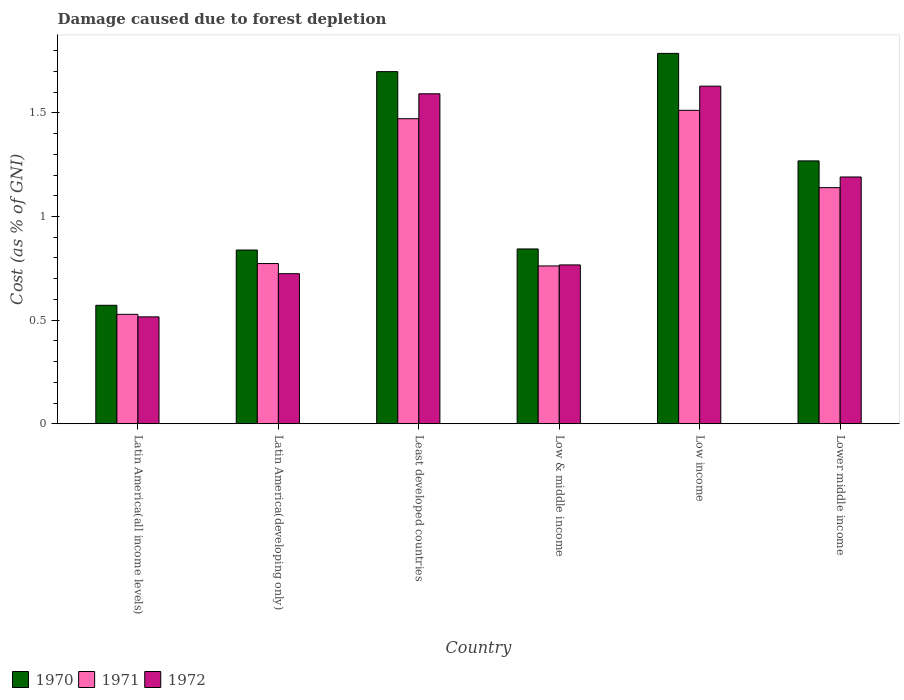How many groups of bars are there?
Provide a short and direct response. 6. Are the number of bars per tick equal to the number of legend labels?
Offer a very short reply. Yes. Are the number of bars on each tick of the X-axis equal?
Give a very brief answer. Yes. How many bars are there on the 5th tick from the right?
Keep it short and to the point. 3. What is the label of the 1st group of bars from the left?
Your answer should be compact. Latin America(all income levels). What is the cost of damage caused due to forest depletion in 1971 in Latin America(developing only)?
Your answer should be compact. 0.77. Across all countries, what is the maximum cost of damage caused due to forest depletion in 1970?
Ensure brevity in your answer.  1.79. Across all countries, what is the minimum cost of damage caused due to forest depletion in 1970?
Give a very brief answer. 0.57. In which country was the cost of damage caused due to forest depletion in 1970 minimum?
Offer a very short reply. Latin America(all income levels). What is the total cost of damage caused due to forest depletion in 1970 in the graph?
Ensure brevity in your answer.  7.01. What is the difference between the cost of damage caused due to forest depletion in 1971 in Latin America(all income levels) and that in Least developed countries?
Your answer should be very brief. -0.94. What is the difference between the cost of damage caused due to forest depletion in 1972 in Low & middle income and the cost of damage caused due to forest depletion in 1970 in Least developed countries?
Ensure brevity in your answer.  -0.93. What is the average cost of damage caused due to forest depletion in 1972 per country?
Ensure brevity in your answer.  1.07. What is the difference between the cost of damage caused due to forest depletion of/in 1971 and cost of damage caused due to forest depletion of/in 1970 in Low income?
Provide a short and direct response. -0.27. In how many countries, is the cost of damage caused due to forest depletion in 1970 greater than 0.6 %?
Your response must be concise. 5. What is the ratio of the cost of damage caused due to forest depletion in 1972 in Latin America(all income levels) to that in Latin America(developing only)?
Give a very brief answer. 0.71. Is the cost of damage caused due to forest depletion in 1972 in Latin America(all income levels) less than that in Low income?
Offer a very short reply. Yes. Is the difference between the cost of damage caused due to forest depletion in 1971 in Latin America(all income levels) and Low income greater than the difference between the cost of damage caused due to forest depletion in 1970 in Latin America(all income levels) and Low income?
Your answer should be compact. Yes. What is the difference between the highest and the second highest cost of damage caused due to forest depletion in 1970?
Provide a short and direct response. 0.09. What is the difference between the highest and the lowest cost of damage caused due to forest depletion in 1972?
Your answer should be very brief. 1.11. In how many countries, is the cost of damage caused due to forest depletion in 1970 greater than the average cost of damage caused due to forest depletion in 1970 taken over all countries?
Provide a succinct answer. 3. Is the sum of the cost of damage caused due to forest depletion in 1970 in Low income and Lower middle income greater than the maximum cost of damage caused due to forest depletion in 1971 across all countries?
Your answer should be very brief. Yes. Is it the case that in every country, the sum of the cost of damage caused due to forest depletion in 1972 and cost of damage caused due to forest depletion in 1970 is greater than the cost of damage caused due to forest depletion in 1971?
Give a very brief answer. Yes. How many bars are there?
Keep it short and to the point. 18. How many countries are there in the graph?
Your answer should be very brief. 6. What is the difference between two consecutive major ticks on the Y-axis?
Your response must be concise. 0.5. Are the values on the major ticks of Y-axis written in scientific E-notation?
Provide a succinct answer. No. Where does the legend appear in the graph?
Ensure brevity in your answer.  Bottom left. How are the legend labels stacked?
Provide a short and direct response. Horizontal. What is the title of the graph?
Provide a succinct answer. Damage caused due to forest depletion. What is the label or title of the X-axis?
Your answer should be very brief. Country. What is the label or title of the Y-axis?
Make the answer very short. Cost (as % of GNI). What is the Cost (as % of GNI) of 1970 in Latin America(all income levels)?
Provide a short and direct response. 0.57. What is the Cost (as % of GNI) of 1971 in Latin America(all income levels)?
Make the answer very short. 0.53. What is the Cost (as % of GNI) in 1972 in Latin America(all income levels)?
Your answer should be very brief. 0.52. What is the Cost (as % of GNI) in 1970 in Latin America(developing only)?
Keep it short and to the point. 0.84. What is the Cost (as % of GNI) of 1971 in Latin America(developing only)?
Your response must be concise. 0.77. What is the Cost (as % of GNI) in 1972 in Latin America(developing only)?
Your answer should be compact. 0.72. What is the Cost (as % of GNI) in 1970 in Least developed countries?
Give a very brief answer. 1.7. What is the Cost (as % of GNI) in 1971 in Least developed countries?
Your response must be concise. 1.47. What is the Cost (as % of GNI) of 1972 in Least developed countries?
Your response must be concise. 1.59. What is the Cost (as % of GNI) in 1970 in Low & middle income?
Keep it short and to the point. 0.84. What is the Cost (as % of GNI) of 1971 in Low & middle income?
Your answer should be compact. 0.76. What is the Cost (as % of GNI) of 1972 in Low & middle income?
Ensure brevity in your answer.  0.77. What is the Cost (as % of GNI) of 1970 in Low income?
Make the answer very short. 1.79. What is the Cost (as % of GNI) of 1971 in Low income?
Provide a succinct answer. 1.51. What is the Cost (as % of GNI) in 1972 in Low income?
Provide a succinct answer. 1.63. What is the Cost (as % of GNI) in 1970 in Lower middle income?
Offer a very short reply. 1.27. What is the Cost (as % of GNI) of 1971 in Lower middle income?
Make the answer very short. 1.14. What is the Cost (as % of GNI) in 1972 in Lower middle income?
Ensure brevity in your answer.  1.19. Across all countries, what is the maximum Cost (as % of GNI) of 1970?
Provide a succinct answer. 1.79. Across all countries, what is the maximum Cost (as % of GNI) in 1971?
Make the answer very short. 1.51. Across all countries, what is the maximum Cost (as % of GNI) in 1972?
Your answer should be very brief. 1.63. Across all countries, what is the minimum Cost (as % of GNI) in 1970?
Make the answer very short. 0.57. Across all countries, what is the minimum Cost (as % of GNI) in 1971?
Make the answer very short. 0.53. Across all countries, what is the minimum Cost (as % of GNI) in 1972?
Provide a short and direct response. 0.52. What is the total Cost (as % of GNI) in 1970 in the graph?
Ensure brevity in your answer.  7.01. What is the total Cost (as % of GNI) of 1971 in the graph?
Your response must be concise. 6.19. What is the total Cost (as % of GNI) of 1972 in the graph?
Your response must be concise. 6.42. What is the difference between the Cost (as % of GNI) in 1970 in Latin America(all income levels) and that in Latin America(developing only)?
Your answer should be compact. -0.27. What is the difference between the Cost (as % of GNI) of 1971 in Latin America(all income levels) and that in Latin America(developing only)?
Ensure brevity in your answer.  -0.25. What is the difference between the Cost (as % of GNI) of 1972 in Latin America(all income levels) and that in Latin America(developing only)?
Offer a terse response. -0.21. What is the difference between the Cost (as % of GNI) of 1970 in Latin America(all income levels) and that in Least developed countries?
Your response must be concise. -1.13. What is the difference between the Cost (as % of GNI) in 1971 in Latin America(all income levels) and that in Least developed countries?
Offer a very short reply. -0.94. What is the difference between the Cost (as % of GNI) of 1972 in Latin America(all income levels) and that in Least developed countries?
Give a very brief answer. -1.08. What is the difference between the Cost (as % of GNI) of 1970 in Latin America(all income levels) and that in Low & middle income?
Offer a very short reply. -0.27. What is the difference between the Cost (as % of GNI) in 1971 in Latin America(all income levels) and that in Low & middle income?
Your response must be concise. -0.23. What is the difference between the Cost (as % of GNI) of 1972 in Latin America(all income levels) and that in Low & middle income?
Keep it short and to the point. -0.25. What is the difference between the Cost (as % of GNI) in 1970 in Latin America(all income levels) and that in Low income?
Make the answer very short. -1.22. What is the difference between the Cost (as % of GNI) of 1971 in Latin America(all income levels) and that in Low income?
Your response must be concise. -0.98. What is the difference between the Cost (as % of GNI) in 1972 in Latin America(all income levels) and that in Low income?
Make the answer very short. -1.11. What is the difference between the Cost (as % of GNI) in 1970 in Latin America(all income levels) and that in Lower middle income?
Provide a succinct answer. -0.7. What is the difference between the Cost (as % of GNI) in 1971 in Latin America(all income levels) and that in Lower middle income?
Provide a succinct answer. -0.61. What is the difference between the Cost (as % of GNI) in 1972 in Latin America(all income levels) and that in Lower middle income?
Keep it short and to the point. -0.68. What is the difference between the Cost (as % of GNI) in 1970 in Latin America(developing only) and that in Least developed countries?
Your answer should be compact. -0.86. What is the difference between the Cost (as % of GNI) in 1971 in Latin America(developing only) and that in Least developed countries?
Your answer should be compact. -0.7. What is the difference between the Cost (as % of GNI) of 1972 in Latin America(developing only) and that in Least developed countries?
Provide a succinct answer. -0.87. What is the difference between the Cost (as % of GNI) of 1970 in Latin America(developing only) and that in Low & middle income?
Your response must be concise. -0.01. What is the difference between the Cost (as % of GNI) in 1971 in Latin America(developing only) and that in Low & middle income?
Offer a terse response. 0.01. What is the difference between the Cost (as % of GNI) in 1972 in Latin America(developing only) and that in Low & middle income?
Give a very brief answer. -0.04. What is the difference between the Cost (as % of GNI) of 1970 in Latin America(developing only) and that in Low income?
Keep it short and to the point. -0.95. What is the difference between the Cost (as % of GNI) of 1971 in Latin America(developing only) and that in Low income?
Offer a terse response. -0.74. What is the difference between the Cost (as % of GNI) in 1972 in Latin America(developing only) and that in Low income?
Your answer should be compact. -0.9. What is the difference between the Cost (as % of GNI) in 1970 in Latin America(developing only) and that in Lower middle income?
Provide a short and direct response. -0.43. What is the difference between the Cost (as % of GNI) in 1971 in Latin America(developing only) and that in Lower middle income?
Keep it short and to the point. -0.37. What is the difference between the Cost (as % of GNI) of 1972 in Latin America(developing only) and that in Lower middle income?
Offer a very short reply. -0.47. What is the difference between the Cost (as % of GNI) in 1970 in Least developed countries and that in Low & middle income?
Your answer should be compact. 0.86. What is the difference between the Cost (as % of GNI) in 1971 in Least developed countries and that in Low & middle income?
Offer a very short reply. 0.71. What is the difference between the Cost (as % of GNI) in 1972 in Least developed countries and that in Low & middle income?
Make the answer very short. 0.83. What is the difference between the Cost (as % of GNI) in 1970 in Least developed countries and that in Low income?
Your response must be concise. -0.09. What is the difference between the Cost (as % of GNI) of 1971 in Least developed countries and that in Low income?
Your answer should be compact. -0.04. What is the difference between the Cost (as % of GNI) of 1972 in Least developed countries and that in Low income?
Your answer should be very brief. -0.04. What is the difference between the Cost (as % of GNI) of 1970 in Least developed countries and that in Lower middle income?
Give a very brief answer. 0.43. What is the difference between the Cost (as % of GNI) of 1971 in Least developed countries and that in Lower middle income?
Make the answer very short. 0.33. What is the difference between the Cost (as % of GNI) of 1972 in Least developed countries and that in Lower middle income?
Keep it short and to the point. 0.4. What is the difference between the Cost (as % of GNI) in 1970 in Low & middle income and that in Low income?
Provide a short and direct response. -0.94. What is the difference between the Cost (as % of GNI) of 1971 in Low & middle income and that in Low income?
Make the answer very short. -0.75. What is the difference between the Cost (as % of GNI) of 1972 in Low & middle income and that in Low income?
Provide a succinct answer. -0.86. What is the difference between the Cost (as % of GNI) in 1970 in Low & middle income and that in Lower middle income?
Your answer should be very brief. -0.42. What is the difference between the Cost (as % of GNI) in 1971 in Low & middle income and that in Lower middle income?
Provide a succinct answer. -0.38. What is the difference between the Cost (as % of GNI) in 1972 in Low & middle income and that in Lower middle income?
Keep it short and to the point. -0.42. What is the difference between the Cost (as % of GNI) in 1970 in Low income and that in Lower middle income?
Your answer should be very brief. 0.52. What is the difference between the Cost (as % of GNI) of 1971 in Low income and that in Lower middle income?
Ensure brevity in your answer.  0.37. What is the difference between the Cost (as % of GNI) in 1972 in Low income and that in Lower middle income?
Keep it short and to the point. 0.44. What is the difference between the Cost (as % of GNI) in 1970 in Latin America(all income levels) and the Cost (as % of GNI) in 1971 in Latin America(developing only)?
Your response must be concise. -0.2. What is the difference between the Cost (as % of GNI) of 1970 in Latin America(all income levels) and the Cost (as % of GNI) of 1972 in Latin America(developing only)?
Keep it short and to the point. -0.15. What is the difference between the Cost (as % of GNI) of 1971 in Latin America(all income levels) and the Cost (as % of GNI) of 1972 in Latin America(developing only)?
Your response must be concise. -0.2. What is the difference between the Cost (as % of GNI) of 1970 in Latin America(all income levels) and the Cost (as % of GNI) of 1971 in Least developed countries?
Provide a succinct answer. -0.9. What is the difference between the Cost (as % of GNI) of 1970 in Latin America(all income levels) and the Cost (as % of GNI) of 1972 in Least developed countries?
Your response must be concise. -1.02. What is the difference between the Cost (as % of GNI) in 1971 in Latin America(all income levels) and the Cost (as % of GNI) in 1972 in Least developed countries?
Your response must be concise. -1.06. What is the difference between the Cost (as % of GNI) in 1970 in Latin America(all income levels) and the Cost (as % of GNI) in 1971 in Low & middle income?
Provide a short and direct response. -0.19. What is the difference between the Cost (as % of GNI) of 1970 in Latin America(all income levels) and the Cost (as % of GNI) of 1972 in Low & middle income?
Make the answer very short. -0.19. What is the difference between the Cost (as % of GNI) in 1971 in Latin America(all income levels) and the Cost (as % of GNI) in 1972 in Low & middle income?
Your response must be concise. -0.24. What is the difference between the Cost (as % of GNI) of 1970 in Latin America(all income levels) and the Cost (as % of GNI) of 1971 in Low income?
Offer a terse response. -0.94. What is the difference between the Cost (as % of GNI) of 1970 in Latin America(all income levels) and the Cost (as % of GNI) of 1972 in Low income?
Keep it short and to the point. -1.06. What is the difference between the Cost (as % of GNI) of 1971 in Latin America(all income levels) and the Cost (as % of GNI) of 1972 in Low income?
Your answer should be very brief. -1.1. What is the difference between the Cost (as % of GNI) of 1970 in Latin America(all income levels) and the Cost (as % of GNI) of 1971 in Lower middle income?
Offer a very short reply. -0.57. What is the difference between the Cost (as % of GNI) of 1970 in Latin America(all income levels) and the Cost (as % of GNI) of 1972 in Lower middle income?
Offer a terse response. -0.62. What is the difference between the Cost (as % of GNI) in 1971 in Latin America(all income levels) and the Cost (as % of GNI) in 1972 in Lower middle income?
Your response must be concise. -0.66. What is the difference between the Cost (as % of GNI) in 1970 in Latin America(developing only) and the Cost (as % of GNI) in 1971 in Least developed countries?
Your answer should be very brief. -0.63. What is the difference between the Cost (as % of GNI) in 1970 in Latin America(developing only) and the Cost (as % of GNI) in 1972 in Least developed countries?
Your answer should be very brief. -0.75. What is the difference between the Cost (as % of GNI) of 1971 in Latin America(developing only) and the Cost (as % of GNI) of 1972 in Least developed countries?
Ensure brevity in your answer.  -0.82. What is the difference between the Cost (as % of GNI) in 1970 in Latin America(developing only) and the Cost (as % of GNI) in 1971 in Low & middle income?
Make the answer very short. 0.08. What is the difference between the Cost (as % of GNI) in 1970 in Latin America(developing only) and the Cost (as % of GNI) in 1972 in Low & middle income?
Your answer should be compact. 0.07. What is the difference between the Cost (as % of GNI) in 1971 in Latin America(developing only) and the Cost (as % of GNI) in 1972 in Low & middle income?
Offer a very short reply. 0.01. What is the difference between the Cost (as % of GNI) of 1970 in Latin America(developing only) and the Cost (as % of GNI) of 1971 in Low income?
Offer a terse response. -0.67. What is the difference between the Cost (as % of GNI) in 1970 in Latin America(developing only) and the Cost (as % of GNI) in 1972 in Low income?
Your response must be concise. -0.79. What is the difference between the Cost (as % of GNI) in 1971 in Latin America(developing only) and the Cost (as % of GNI) in 1972 in Low income?
Offer a terse response. -0.86. What is the difference between the Cost (as % of GNI) in 1970 in Latin America(developing only) and the Cost (as % of GNI) in 1971 in Lower middle income?
Make the answer very short. -0.3. What is the difference between the Cost (as % of GNI) in 1970 in Latin America(developing only) and the Cost (as % of GNI) in 1972 in Lower middle income?
Keep it short and to the point. -0.35. What is the difference between the Cost (as % of GNI) in 1971 in Latin America(developing only) and the Cost (as % of GNI) in 1972 in Lower middle income?
Your response must be concise. -0.42. What is the difference between the Cost (as % of GNI) in 1970 in Least developed countries and the Cost (as % of GNI) in 1971 in Low & middle income?
Ensure brevity in your answer.  0.94. What is the difference between the Cost (as % of GNI) of 1970 in Least developed countries and the Cost (as % of GNI) of 1972 in Low & middle income?
Your answer should be compact. 0.93. What is the difference between the Cost (as % of GNI) of 1971 in Least developed countries and the Cost (as % of GNI) of 1972 in Low & middle income?
Offer a very short reply. 0.71. What is the difference between the Cost (as % of GNI) in 1970 in Least developed countries and the Cost (as % of GNI) in 1971 in Low income?
Your response must be concise. 0.19. What is the difference between the Cost (as % of GNI) in 1970 in Least developed countries and the Cost (as % of GNI) in 1972 in Low income?
Your answer should be compact. 0.07. What is the difference between the Cost (as % of GNI) in 1971 in Least developed countries and the Cost (as % of GNI) in 1972 in Low income?
Make the answer very short. -0.16. What is the difference between the Cost (as % of GNI) in 1970 in Least developed countries and the Cost (as % of GNI) in 1971 in Lower middle income?
Offer a terse response. 0.56. What is the difference between the Cost (as % of GNI) in 1970 in Least developed countries and the Cost (as % of GNI) in 1972 in Lower middle income?
Ensure brevity in your answer.  0.51. What is the difference between the Cost (as % of GNI) of 1971 in Least developed countries and the Cost (as % of GNI) of 1972 in Lower middle income?
Offer a terse response. 0.28. What is the difference between the Cost (as % of GNI) in 1970 in Low & middle income and the Cost (as % of GNI) in 1971 in Low income?
Ensure brevity in your answer.  -0.67. What is the difference between the Cost (as % of GNI) in 1970 in Low & middle income and the Cost (as % of GNI) in 1972 in Low income?
Offer a very short reply. -0.79. What is the difference between the Cost (as % of GNI) of 1971 in Low & middle income and the Cost (as % of GNI) of 1972 in Low income?
Your response must be concise. -0.87. What is the difference between the Cost (as % of GNI) of 1970 in Low & middle income and the Cost (as % of GNI) of 1971 in Lower middle income?
Offer a very short reply. -0.3. What is the difference between the Cost (as % of GNI) in 1970 in Low & middle income and the Cost (as % of GNI) in 1972 in Lower middle income?
Keep it short and to the point. -0.35. What is the difference between the Cost (as % of GNI) of 1971 in Low & middle income and the Cost (as % of GNI) of 1972 in Lower middle income?
Ensure brevity in your answer.  -0.43. What is the difference between the Cost (as % of GNI) in 1970 in Low income and the Cost (as % of GNI) in 1971 in Lower middle income?
Offer a very short reply. 0.65. What is the difference between the Cost (as % of GNI) in 1970 in Low income and the Cost (as % of GNI) in 1972 in Lower middle income?
Ensure brevity in your answer.  0.6. What is the difference between the Cost (as % of GNI) of 1971 in Low income and the Cost (as % of GNI) of 1972 in Lower middle income?
Give a very brief answer. 0.32. What is the average Cost (as % of GNI) of 1970 per country?
Your answer should be compact. 1.17. What is the average Cost (as % of GNI) of 1971 per country?
Your answer should be compact. 1.03. What is the average Cost (as % of GNI) of 1972 per country?
Provide a succinct answer. 1.07. What is the difference between the Cost (as % of GNI) of 1970 and Cost (as % of GNI) of 1971 in Latin America(all income levels)?
Your response must be concise. 0.04. What is the difference between the Cost (as % of GNI) of 1970 and Cost (as % of GNI) of 1972 in Latin America(all income levels)?
Offer a terse response. 0.06. What is the difference between the Cost (as % of GNI) in 1971 and Cost (as % of GNI) in 1972 in Latin America(all income levels)?
Ensure brevity in your answer.  0.01. What is the difference between the Cost (as % of GNI) of 1970 and Cost (as % of GNI) of 1971 in Latin America(developing only)?
Your response must be concise. 0.07. What is the difference between the Cost (as % of GNI) of 1970 and Cost (as % of GNI) of 1972 in Latin America(developing only)?
Make the answer very short. 0.11. What is the difference between the Cost (as % of GNI) of 1971 and Cost (as % of GNI) of 1972 in Latin America(developing only)?
Your response must be concise. 0.05. What is the difference between the Cost (as % of GNI) in 1970 and Cost (as % of GNI) in 1971 in Least developed countries?
Offer a terse response. 0.23. What is the difference between the Cost (as % of GNI) of 1970 and Cost (as % of GNI) of 1972 in Least developed countries?
Give a very brief answer. 0.11. What is the difference between the Cost (as % of GNI) of 1971 and Cost (as % of GNI) of 1972 in Least developed countries?
Provide a succinct answer. -0.12. What is the difference between the Cost (as % of GNI) in 1970 and Cost (as % of GNI) in 1971 in Low & middle income?
Provide a succinct answer. 0.08. What is the difference between the Cost (as % of GNI) in 1970 and Cost (as % of GNI) in 1972 in Low & middle income?
Ensure brevity in your answer.  0.08. What is the difference between the Cost (as % of GNI) in 1971 and Cost (as % of GNI) in 1972 in Low & middle income?
Ensure brevity in your answer.  -0. What is the difference between the Cost (as % of GNI) of 1970 and Cost (as % of GNI) of 1971 in Low income?
Offer a terse response. 0.27. What is the difference between the Cost (as % of GNI) in 1970 and Cost (as % of GNI) in 1972 in Low income?
Provide a succinct answer. 0.16. What is the difference between the Cost (as % of GNI) in 1971 and Cost (as % of GNI) in 1972 in Low income?
Offer a very short reply. -0.12. What is the difference between the Cost (as % of GNI) in 1970 and Cost (as % of GNI) in 1971 in Lower middle income?
Your answer should be compact. 0.13. What is the difference between the Cost (as % of GNI) of 1970 and Cost (as % of GNI) of 1972 in Lower middle income?
Make the answer very short. 0.08. What is the difference between the Cost (as % of GNI) in 1971 and Cost (as % of GNI) in 1972 in Lower middle income?
Offer a terse response. -0.05. What is the ratio of the Cost (as % of GNI) in 1970 in Latin America(all income levels) to that in Latin America(developing only)?
Your response must be concise. 0.68. What is the ratio of the Cost (as % of GNI) in 1971 in Latin America(all income levels) to that in Latin America(developing only)?
Keep it short and to the point. 0.68. What is the ratio of the Cost (as % of GNI) of 1972 in Latin America(all income levels) to that in Latin America(developing only)?
Provide a short and direct response. 0.71. What is the ratio of the Cost (as % of GNI) of 1970 in Latin America(all income levels) to that in Least developed countries?
Provide a succinct answer. 0.34. What is the ratio of the Cost (as % of GNI) in 1971 in Latin America(all income levels) to that in Least developed countries?
Provide a succinct answer. 0.36. What is the ratio of the Cost (as % of GNI) in 1972 in Latin America(all income levels) to that in Least developed countries?
Ensure brevity in your answer.  0.32. What is the ratio of the Cost (as % of GNI) in 1970 in Latin America(all income levels) to that in Low & middle income?
Provide a short and direct response. 0.68. What is the ratio of the Cost (as % of GNI) of 1971 in Latin America(all income levels) to that in Low & middle income?
Make the answer very short. 0.69. What is the ratio of the Cost (as % of GNI) of 1972 in Latin America(all income levels) to that in Low & middle income?
Offer a very short reply. 0.67. What is the ratio of the Cost (as % of GNI) in 1970 in Latin America(all income levels) to that in Low income?
Give a very brief answer. 0.32. What is the ratio of the Cost (as % of GNI) in 1971 in Latin America(all income levels) to that in Low income?
Offer a terse response. 0.35. What is the ratio of the Cost (as % of GNI) in 1972 in Latin America(all income levels) to that in Low income?
Give a very brief answer. 0.32. What is the ratio of the Cost (as % of GNI) of 1970 in Latin America(all income levels) to that in Lower middle income?
Offer a very short reply. 0.45. What is the ratio of the Cost (as % of GNI) of 1971 in Latin America(all income levels) to that in Lower middle income?
Ensure brevity in your answer.  0.46. What is the ratio of the Cost (as % of GNI) of 1972 in Latin America(all income levels) to that in Lower middle income?
Keep it short and to the point. 0.43. What is the ratio of the Cost (as % of GNI) of 1970 in Latin America(developing only) to that in Least developed countries?
Your answer should be very brief. 0.49. What is the ratio of the Cost (as % of GNI) in 1971 in Latin America(developing only) to that in Least developed countries?
Give a very brief answer. 0.53. What is the ratio of the Cost (as % of GNI) in 1972 in Latin America(developing only) to that in Least developed countries?
Ensure brevity in your answer.  0.45. What is the ratio of the Cost (as % of GNI) in 1970 in Latin America(developing only) to that in Low & middle income?
Keep it short and to the point. 0.99. What is the ratio of the Cost (as % of GNI) of 1971 in Latin America(developing only) to that in Low & middle income?
Offer a very short reply. 1.02. What is the ratio of the Cost (as % of GNI) in 1972 in Latin America(developing only) to that in Low & middle income?
Offer a very short reply. 0.94. What is the ratio of the Cost (as % of GNI) of 1970 in Latin America(developing only) to that in Low income?
Make the answer very short. 0.47. What is the ratio of the Cost (as % of GNI) of 1971 in Latin America(developing only) to that in Low income?
Your response must be concise. 0.51. What is the ratio of the Cost (as % of GNI) of 1972 in Latin America(developing only) to that in Low income?
Your answer should be compact. 0.44. What is the ratio of the Cost (as % of GNI) of 1970 in Latin America(developing only) to that in Lower middle income?
Offer a very short reply. 0.66. What is the ratio of the Cost (as % of GNI) in 1971 in Latin America(developing only) to that in Lower middle income?
Your answer should be very brief. 0.68. What is the ratio of the Cost (as % of GNI) in 1972 in Latin America(developing only) to that in Lower middle income?
Make the answer very short. 0.61. What is the ratio of the Cost (as % of GNI) of 1970 in Least developed countries to that in Low & middle income?
Your response must be concise. 2.01. What is the ratio of the Cost (as % of GNI) of 1971 in Least developed countries to that in Low & middle income?
Your response must be concise. 1.93. What is the ratio of the Cost (as % of GNI) of 1972 in Least developed countries to that in Low & middle income?
Give a very brief answer. 2.08. What is the ratio of the Cost (as % of GNI) of 1970 in Least developed countries to that in Low income?
Your response must be concise. 0.95. What is the ratio of the Cost (as % of GNI) of 1971 in Least developed countries to that in Low income?
Your answer should be very brief. 0.97. What is the ratio of the Cost (as % of GNI) of 1972 in Least developed countries to that in Low income?
Offer a very short reply. 0.98. What is the ratio of the Cost (as % of GNI) of 1970 in Least developed countries to that in Lower middle income?
Your answer should be very brief. 1.34. What is the ratio of the Cost (as % of GNI) of 1971 in Least developed countries to that in Lower middle income?
Your answer should be compact. 1.29. What is the ratio of the Cost (as % of GNI) in 1972 in Least developed countries to that in Lower middle income?
Your response must be concise. 1.34. What is the ratio of the Cost (as % of GNI) of 1970 in Low & middle income to that in Low income?
Make the answer very short. 0.47. What is the ratio of the Cost (as % of GNI) in 1971 in Low & middle income to that in Low income?
Offer a very short reply. 0.5. What is the ratio of the Cost (as % of GNI) in 1972 in Low & middle income to that in Low income?
Keep it short and to the point. 0.47. What is the ratio of the Cost (as % of GNI) of 1970 in Low & middle income to that in Lower middle income?
Provide a succinct answer. 0.67. What is the ratio of the Cost (as % of GNI) of 1971 in Low & middle income to that in Lower middle income?
Keep it short and to the point. 0.67. What is the ratio of the Cost (as % of GNI) of 1972 in Low & middle income to that in Lower middle income?
Offer a very short reply. 0.64. What is the ratio of the Cost (as % of GNI) of 1970 in Low income to that in Lower middle income?
Provide a short and direct response. 1.41. What is the ratio of the Cost (as % of GNI) of 1971 in Low income to that in Lower middle income?
Provide a succinct answer. 1.33. What is the ratio of the Cost (as % of GNI) in 1972 in Low income to that in Lower middle income?
Offer a terse response. 1.37. What is the difference between the highest and the second highest Cost (as % of GNI) in 1970?
Your answer should be compact. 0.09. What is the difference between the highest and the second highest Cost (as % of GNI) in 1971?
Your answer should be very brief. 0.04. What is the difference between the highest and the second highest Cost (as % of GNI) of 1972?
Your response must be concise. 0.04. What is the difference between the highest and the lowest Cost (as % of GNI) of 1970?
Offer a terse response. 1.22. What is the difference between the highest and the lowest Cost (as % of GNI) of 1971?
Ensure brevity in your answer.  0.98. What is the difference between the highest and the lowest Cost (as % of GNI) in 1972?
Offer a very short reply. 1.11. 